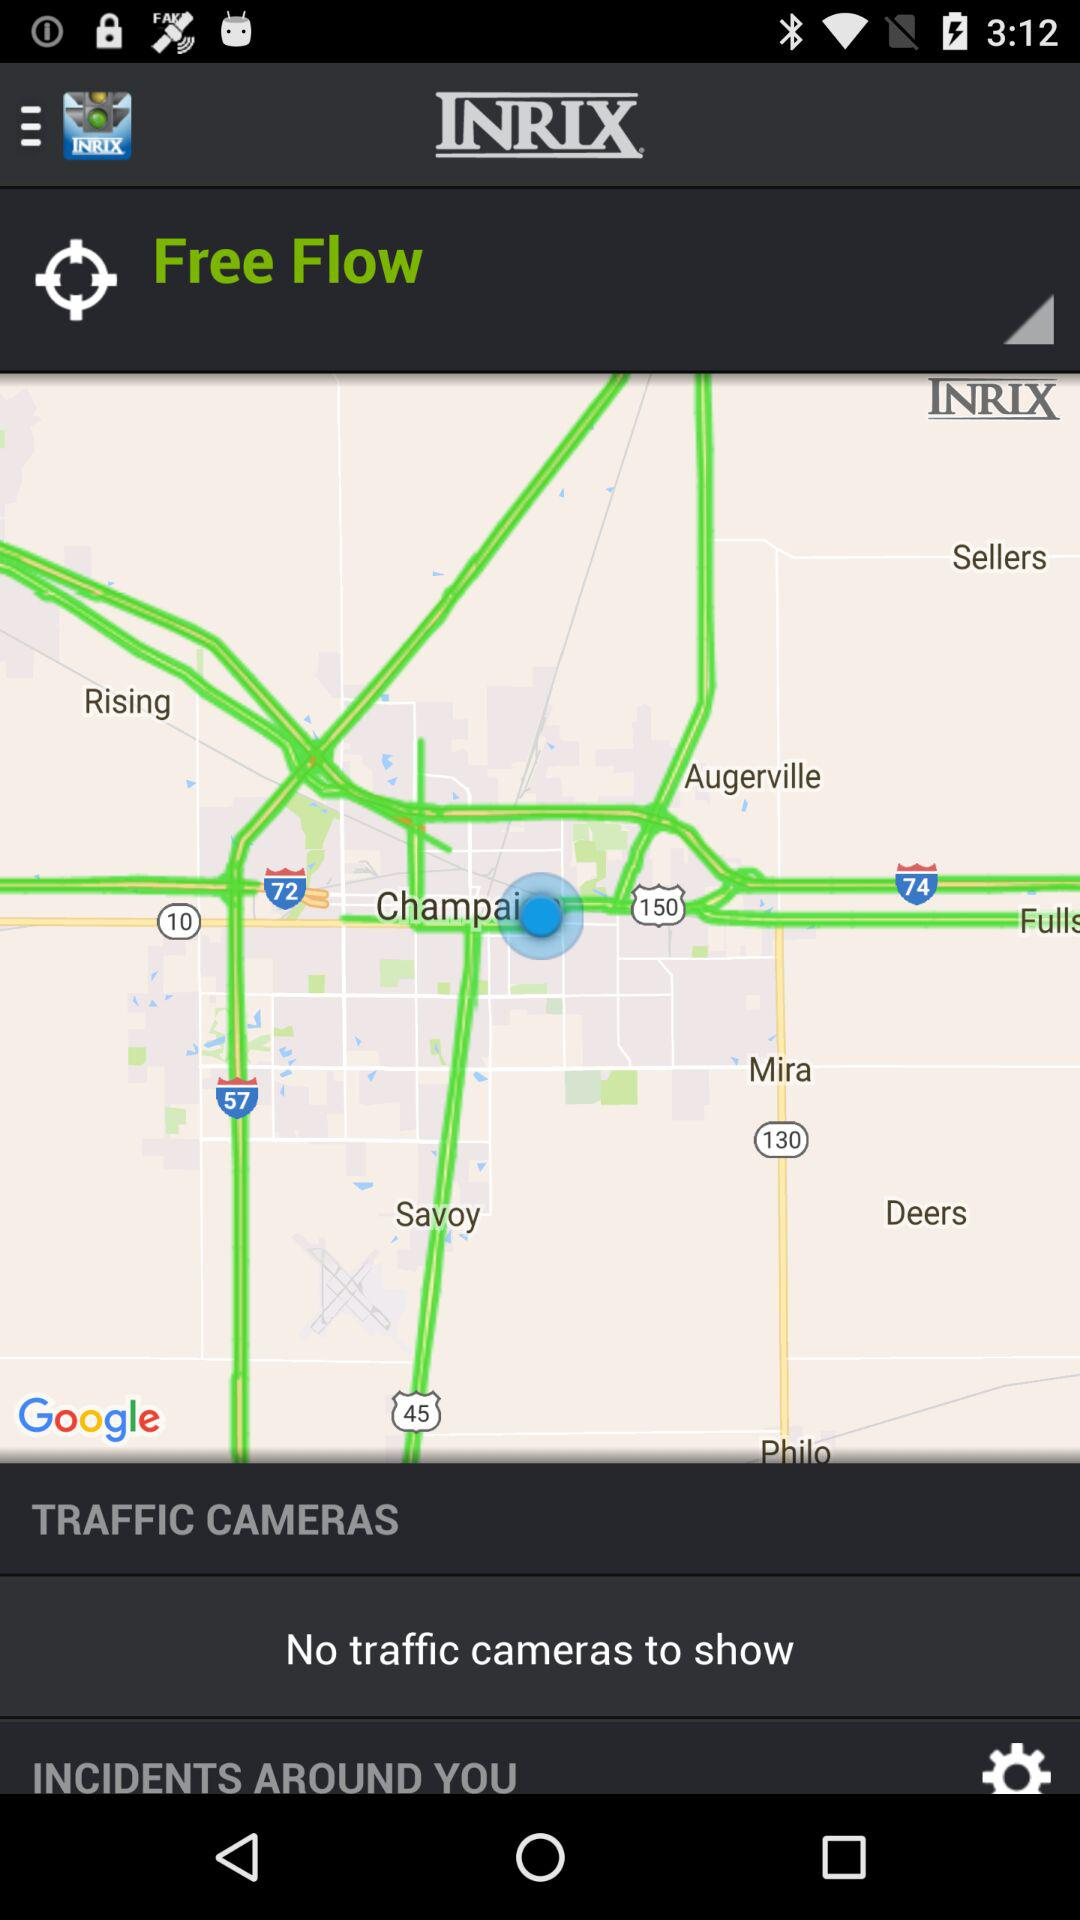Is there any traffic camera to show? There are no traffic cameras to show. 